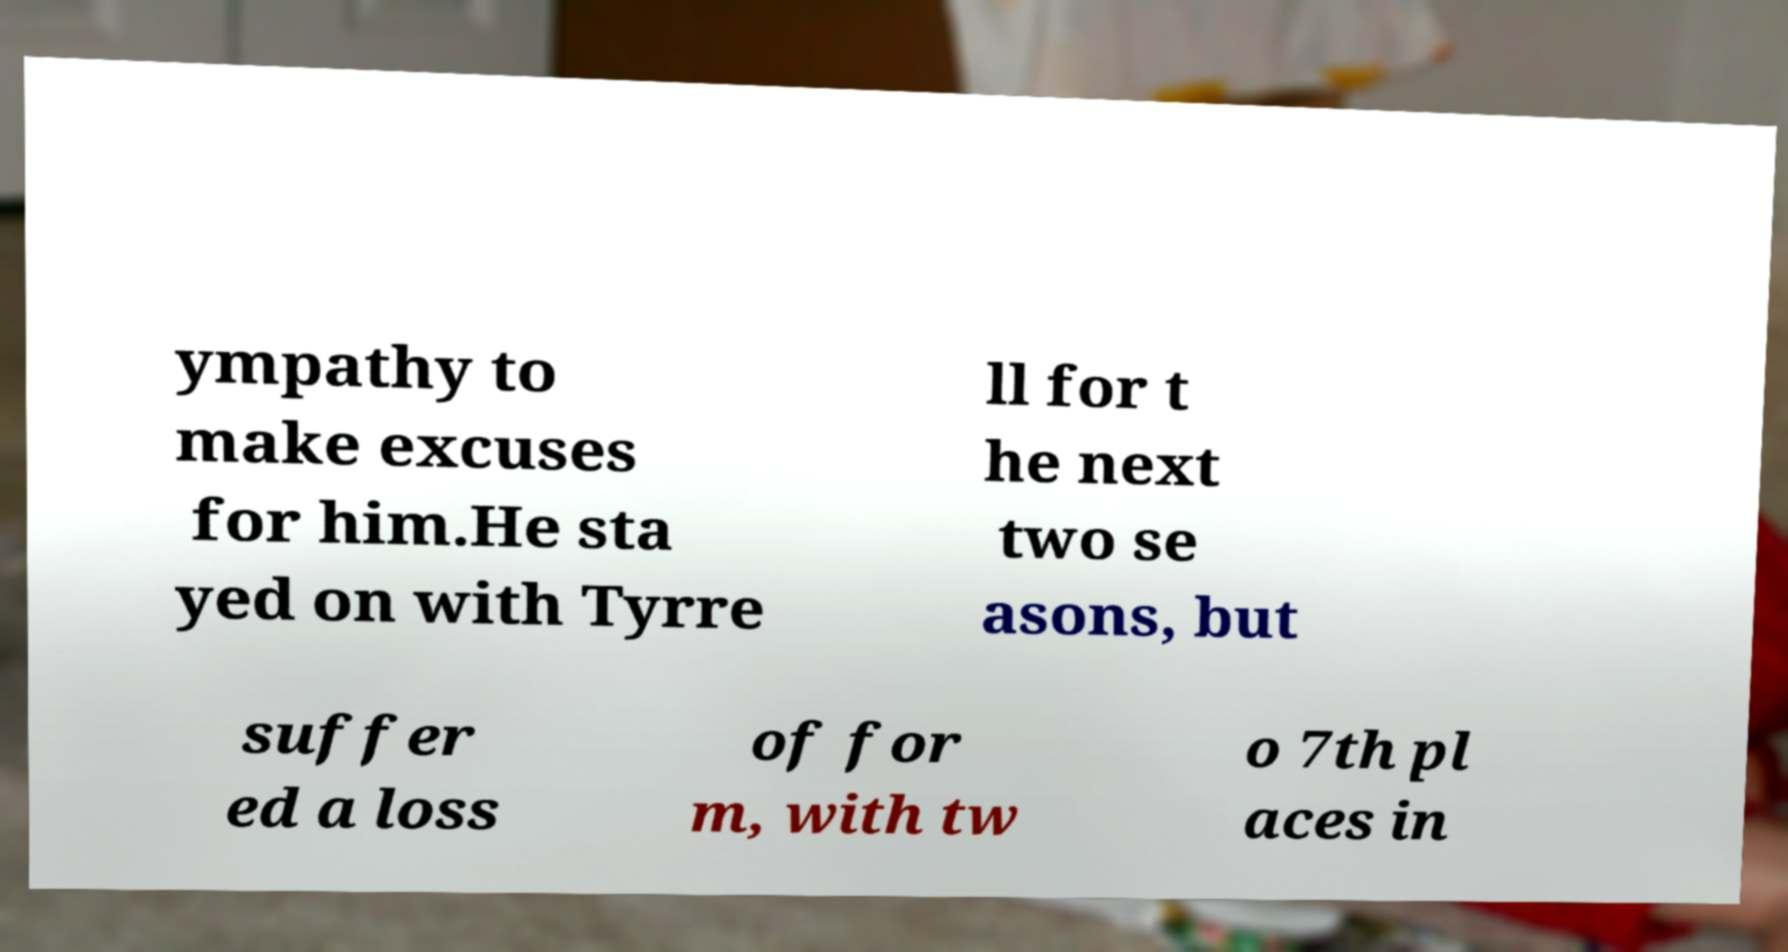I need the written content from this picture converted into text. Can you do that? ympathy to make excuses for him.He sta yed on with Tyrre ll for t he next two se asons, but suffer ed a loss of for m, with tw o 7th pl aces in 